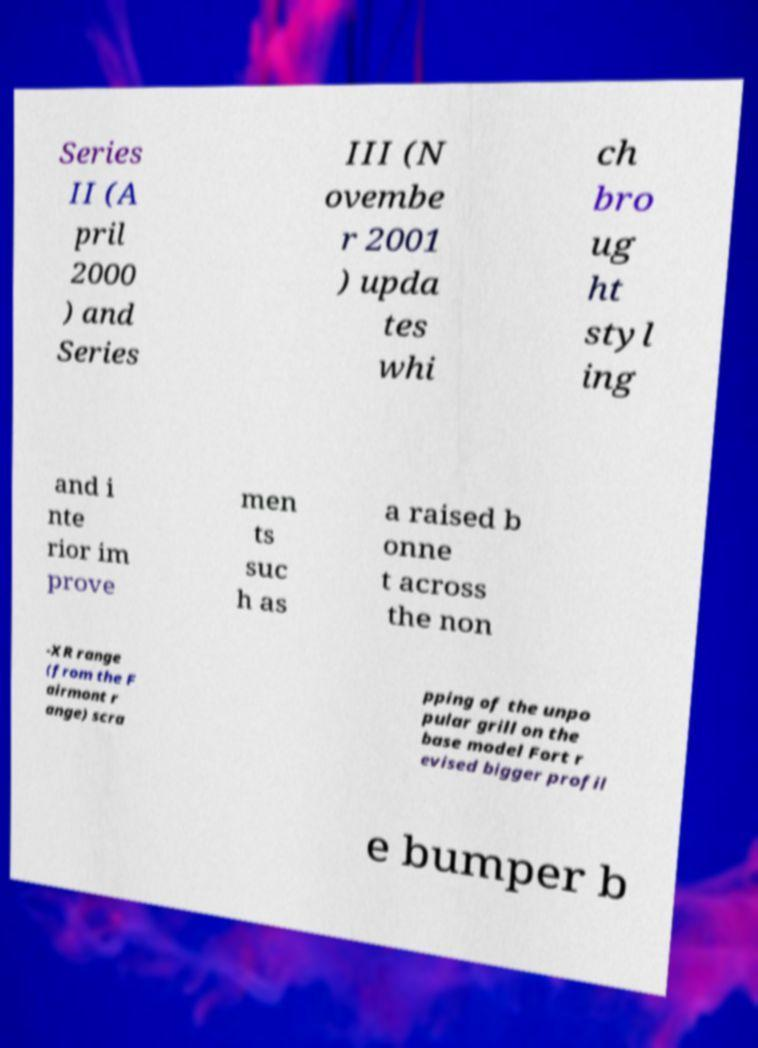Please read and relay the text visible in this image. What does it say? Series II (A pril 2000 ) and Series III (N ovembe r 2001 ) upda tes whi ch bro ug ht styl ing and i nte rior im prove men ts suc h as a raised b onne t across the non -XR range (from the F airmont r ange) scra pping of the unpo pular grill on the base model Fort r evised bigger profil e bumper b 